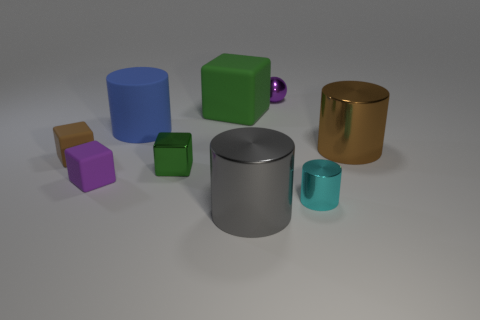How many objects are tiny purple matte blocks or large brown things?
Give a very brief answer. 2. Do the small brown thing and the big cylinder that is in front of the tiny green metallic object have the same material?
Your response must be concise. No. There is a green block behind the small green thing; what is its size?
Your response must be concise. Large. Are there fewer small cyan metal spheres than blue things?
Give a very brief answer. Yes. Are there any tiny metallic spheres that have the same color as the tiny metal cylinder?
Ensure brevity in your answer.  No. There is a object that is on the right side of the large gray thing and in front of the brown metallic cylinder; what shape is it?
Your response must be concise. Cylinder. There is a large thing that is right of the shiny cylinder in front of the cyan object; what shape is it?
Provide a succinct answer. Cylinder. Does the large brown thing have the same shape as the large green thing?
Ensure brevity in your answer.  No. What is the material of the thing that is the same color as the small metal sphere?
Keep it short and to the point. Rubber. Is the color of the large cube the same as the small metallic cylinder?
Your answer should be very brief. No. 